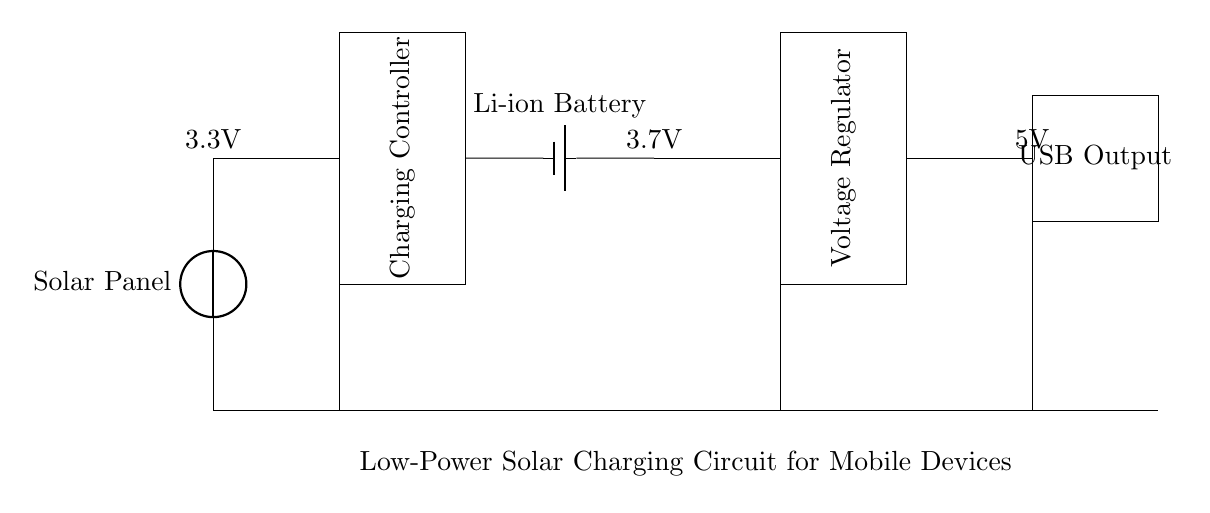What component converts solar energy into electrical energy? The solar panel is the component responsible for converting solar energy into electrical energy, depicted at the left side of the circuit.
Answer: Solar Panel What is the output voltage of the USB connection? The USB output is labeled with an output voltage of 5V, which can be found at the right side of the circuit diagram.
Answer: 5V Which component stores energy for later use? The Li-ion battery is the component that stores energy for later use, indicated next to the charging controller in the circuit diagram.
Answer: Li-ion Battery What is the purpose of the voltage regulator in the circuit? The voltage regulator ensures that the output voltage remains stable at 5V for the USB output, even when the input voltage varies. This function can be deduced from its position in the circuit and its label.
Answer: Stabilize Output Voltage What are the input and output voltage values of the charging controller? The charging controller takes in a voltage of 3.3V from the solar panel and regulates it, allowing it to charge the battery at 3.7V; hence the input and output voltage values are connected in succession.
Answer: 3.3V input, 3.7V output How many main components are there in this circuit? In total, there are 4 main components represented in the circuit diagram: the solar panel, charging controller, Li-ion battery, and voltage regulator with the USB output block as a terminal.
Answer: 4 components What is the function of the ground connections in this circuit? The ground connections provide a common reference point for all components in the circuit, ensuring they operate correctly and safely. It is indicated by the horizontal lines at the bottom of the circuit, providing a return path for current.
Answer: Common Reference Point 